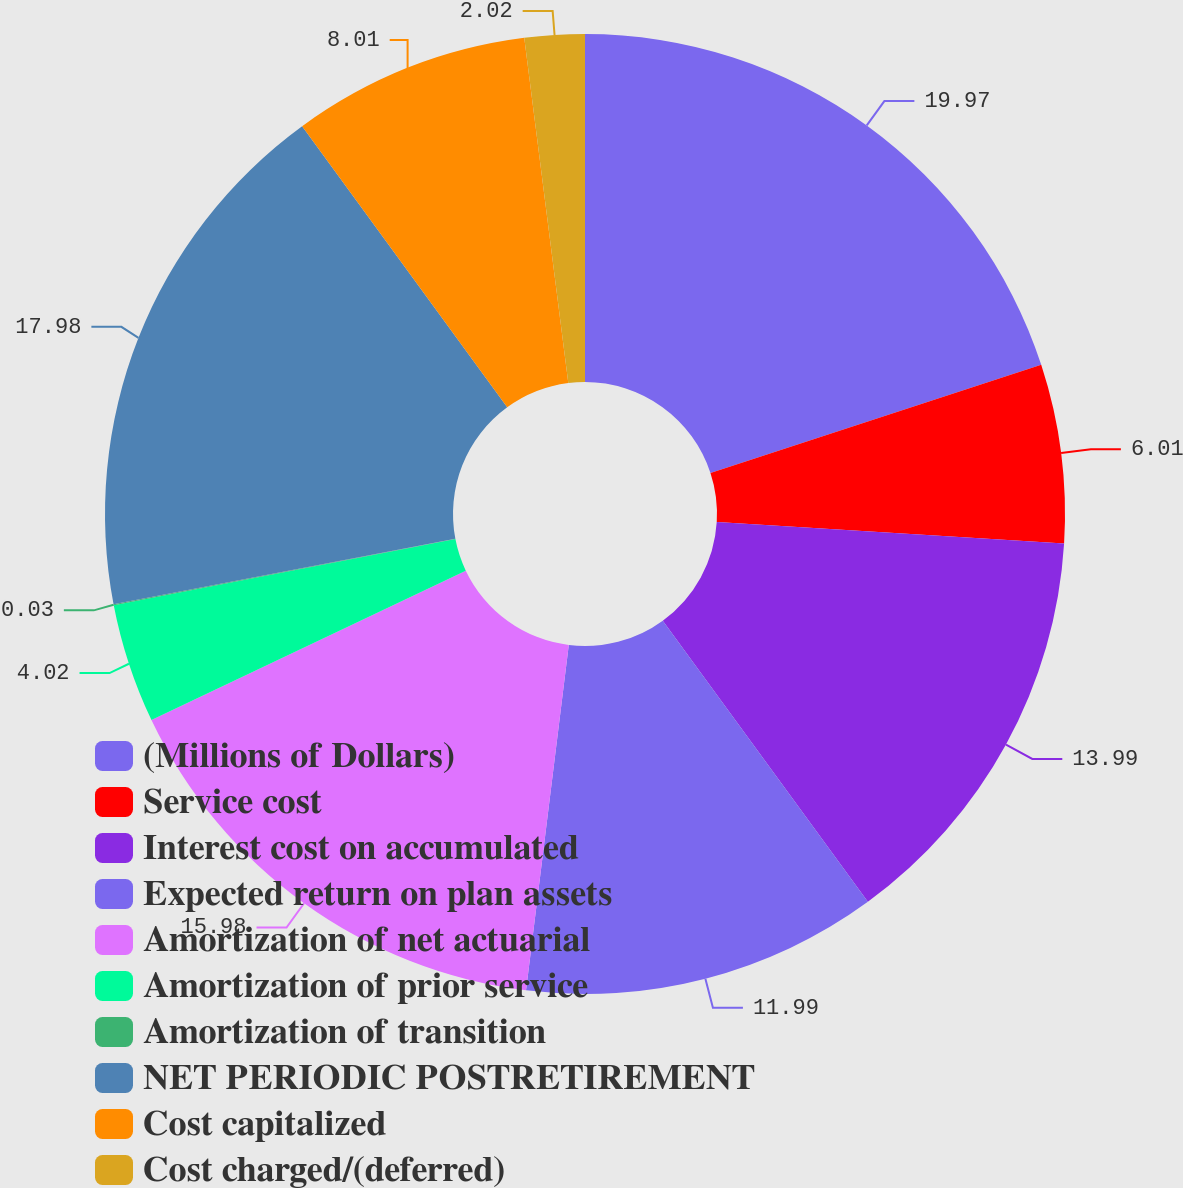<chart> <loc_0><loc_0><loc_500><loc_500><pie_chart><fcel>(Millions of Dollars)<fcel>Service cost<fcel>Interest cost on accumulated<fcel>Expected return on plan assets<fcel>Amortization of net actuarial<fcel>Amortization of prior service<fcel>Amortization of transition<fcel>NET PERIODIC POSTRETIREMENT<fcel>Cost capitalized<fcel>Cost charged/(deferred)<nl><fcel>19.97%<fcel>6.01%<fcel>13.99%<fcel>11.99%<fcel>15.98%<fcel>4.02%<fcel>0.03%<fcel>17.98%<fcel>8.01%<fcel>2.02%<nl></chart> 